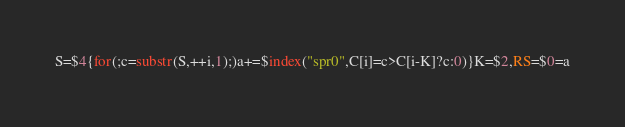Convert code to text. <code><loc_0><loc_0><loc_500><loc_500><_Awk_>S=$4{for(;c=substr(S,++i,1);)a+=$index("spr0",C[i]=c>C[i-K]?c:0)}K=$2,RS=$0=a</code> 